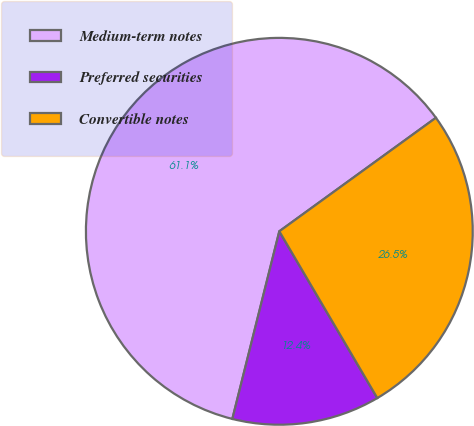Convert chart to OTSL. <chart><loc_0><loc_0><loc_500><loc_500><pie_chart><fcel>Medium-term notes<fcel>Preferred securities<fcel>Convertible notes<nl><fcel>61.11%<fcel>12.36%<fcel>26.53%<nl></chart> 